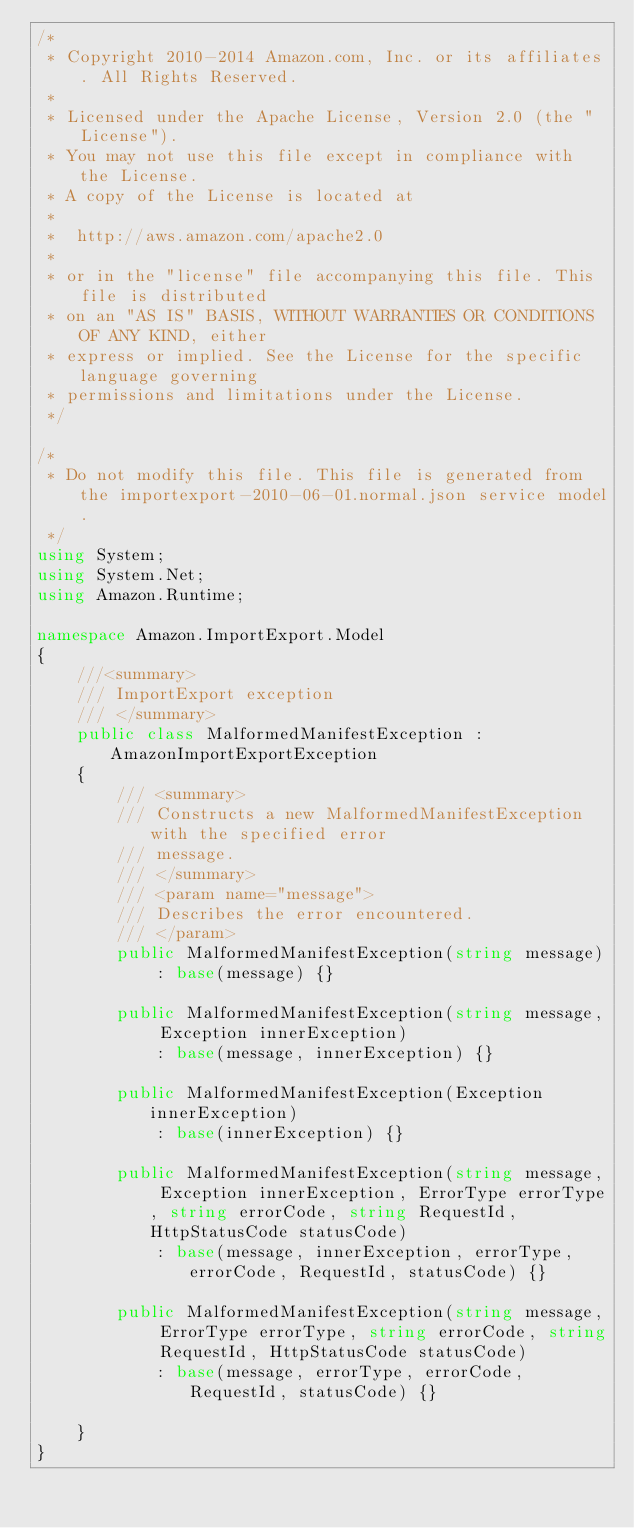Convert code to text. <code><loc_0><loc_0><loc_500><loc_500><_C#_>/*
 * Copyright 2010-2014 Amazon.com, Inc. or its affiliates. All Rights Reserved.
 * 
 * Licensed under the Apache License, Version 2.0 (the "License").
 * You may not use this file except in compliance with the License.
 * A copy of the License is located at
 * 
 *  http://aws.amazon.com/apache2.0
 * 
 * or in the "license" file accompanying this file. This file is distributed
 * on an "AS IS" BASIS, WITHOUT WARRANTIES OR CONDITIONS OF ANY KIND, either
 * express or implied. See the License for the specific language governing
 * permissions and limitations under the License.
 */

/*
 * Do not modify this file. This file is generated from the importexport-2010-06-01.normal.json service model.
 */
using System;
using System.Net;
using Amazon.Runtime;

namespace Amazon.ImportExport.Model
{
    ///<summary>
    /// ImportExport exception
    /// </summary>
    public class MalformedManifestException : AmazonImportExportException 
    {
        /// <summary>
        /// Constructs a new MalformedManifestException with the specified error
        /// message.
        /// </summary>
        /// <param name="message">
        /// Describes the error encountered.
        /// </param>
        public MalformedManifestException(string message) 
            : base(message) {}
          
        public MalformedManifestException(string message, Exception innerException) 
            : base(message, innerException) {}
            
        public MalformedManifestException(Exception innerException) 
            : base(innerException) {}
            
        public MalformedManifestException(string message, Exception innerException, ErrorType errorType, string errorCode, string RequestId, HttpStatusCode statusCode) 
            : base(message, innerException, errorType, errorCode, RequestId, statusCode) {}

        public MalformedManifestException(string message, ErrorType errorType, string errorCode, string RequestId, HttpStatusCode statusCode) 
            : base(message, errorType, errorCode, RequestId, statusCode) {}

    }
}</code> 